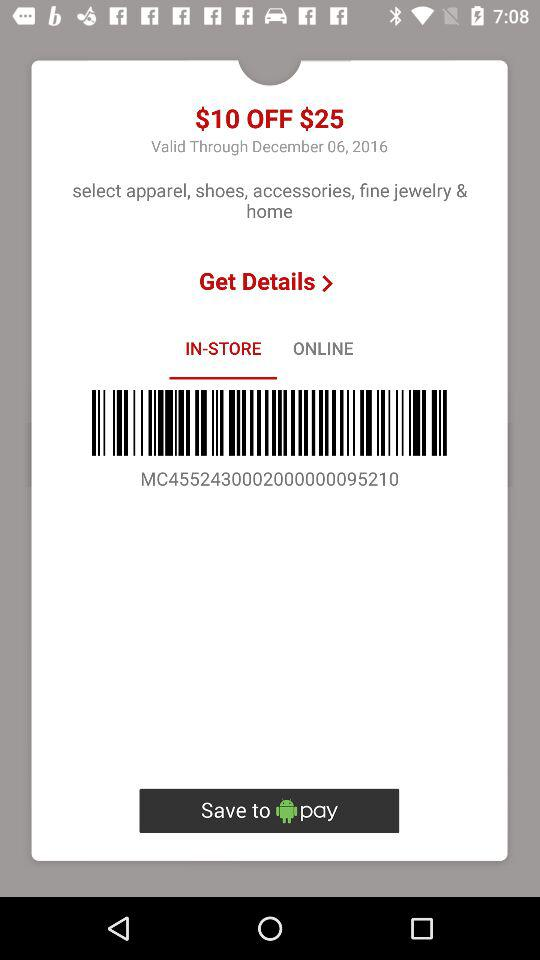What amount is off on $25? The amount that is off is $10. 